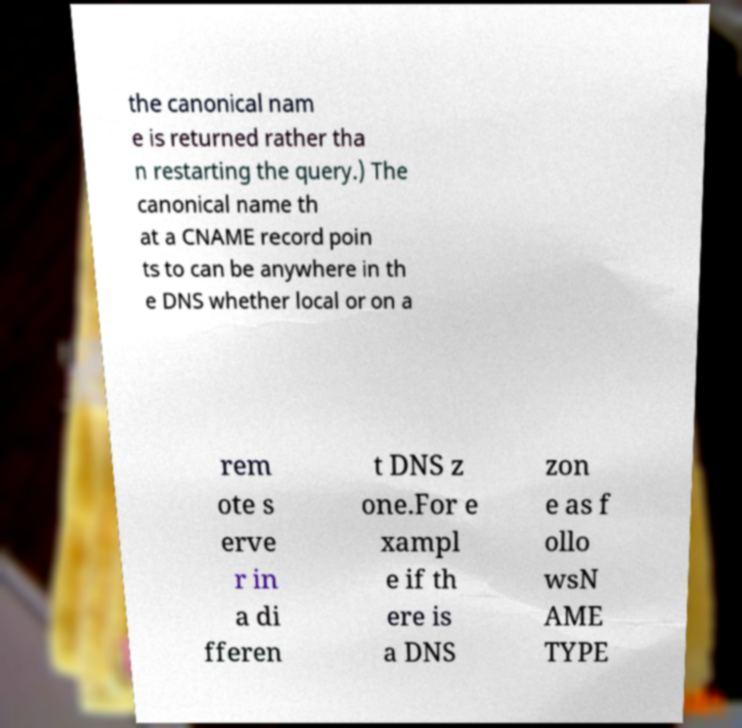Can you read and provide the text displayed in the image?This photo seems to have some interesting text. Can you extract and type it out for me? the canonical nam e is returned rather tha n restarting the query.) The canonical name th at a CNAME record poin ts to can be anywhere in th e DNS whether local or on a rem ote s erve r in a di fferen t DNS z one.For e xampl e if th ere is a DNS zon e as f ollo wsN AME TYPE 